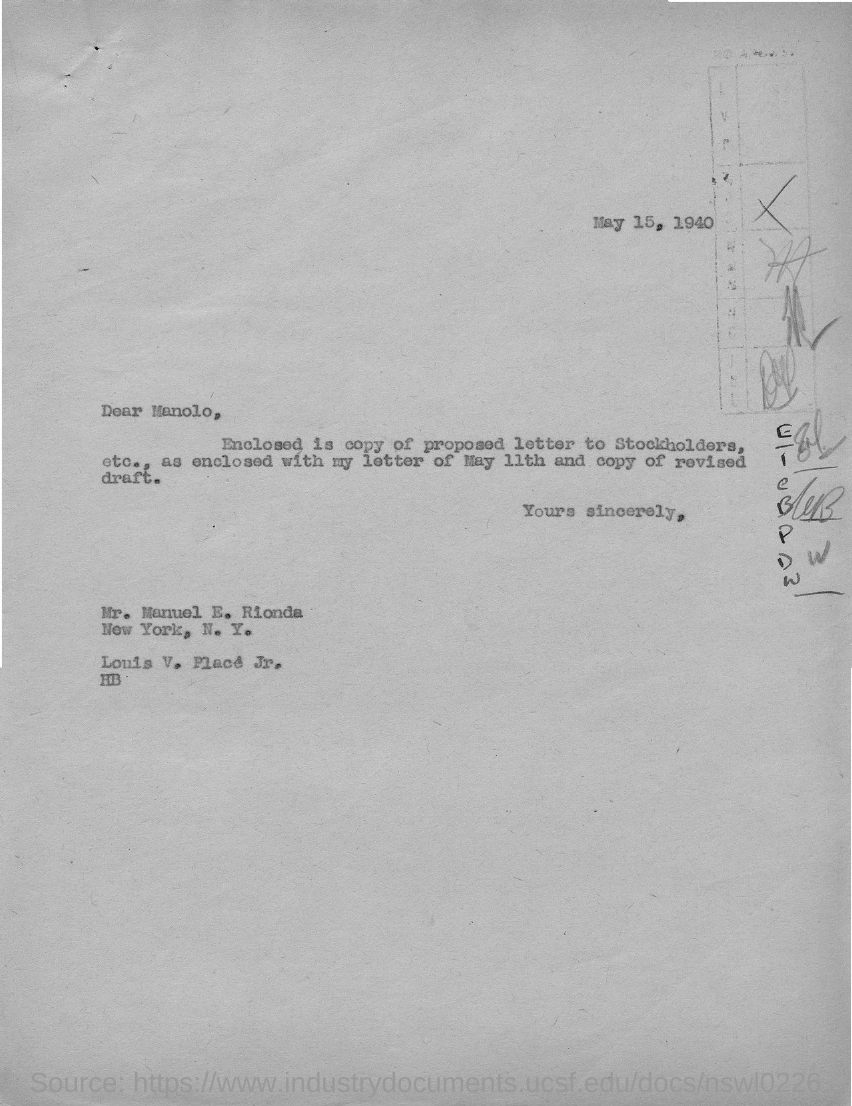Outline some significant characteristics in this image. The addressee of this letter is Manolo. The sender of this letter is MR. MANUEL E. RIONDA. The date mentioned in the letter is May 15, 1940. 